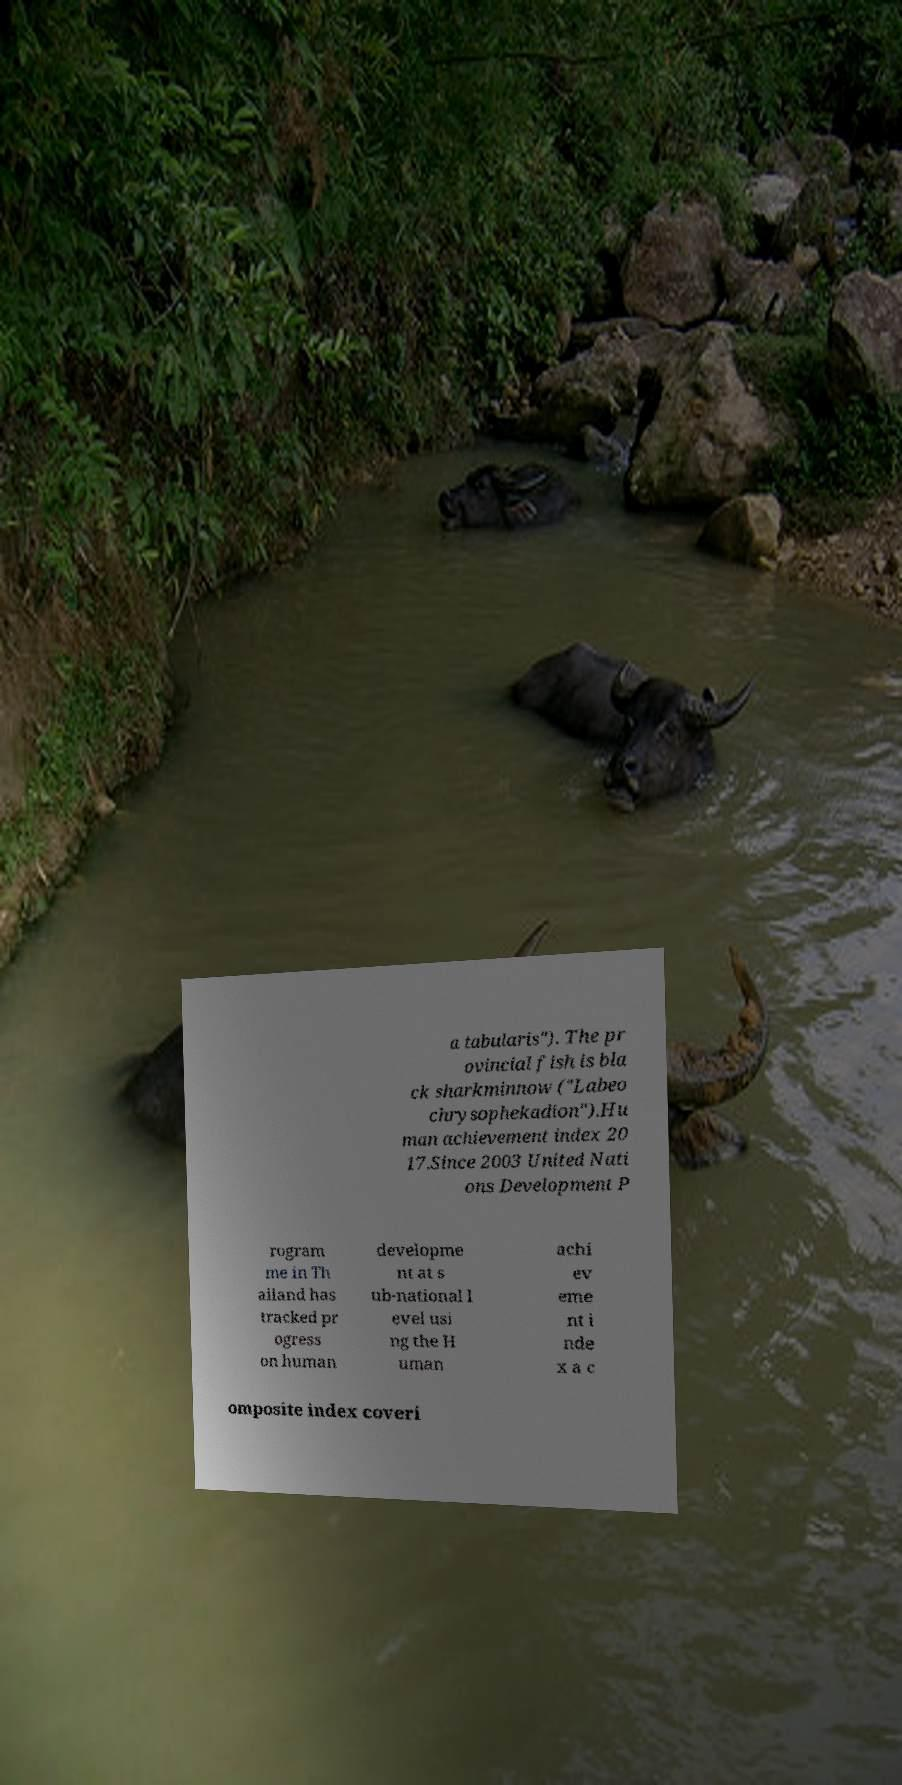Could you assist in decoding the text presented in this image and type it out clearly? a tabularis"). The pr ovincial fish is bla ck sharkminnow ("Labeo chrysophekadion").Hu man achievement index 20 17.Since 2003 United Nati ons Development P rogram me in Th ailand has tracked pr ogress on human developme nt at s ub-national l evel usi ng the H uman achi ev eme nt i nde x a c omposite index coveri 